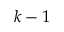Convert formula to latex. <formula><loc_0><loc_0><loc_500><loc_500>k - 1</formula> 